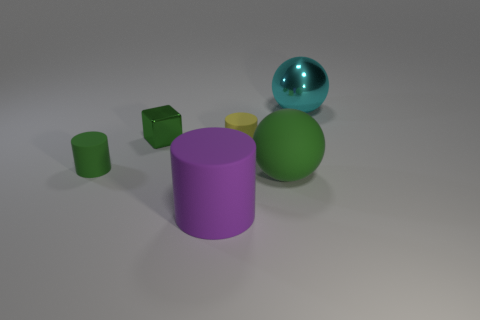Add 2 tiny green cylinders. How many objects exist? 8 Subtract all spheres. How many objects are left? 4 Subtract 0 red balls. How many objects are left? 6 Subtract all large brown cylinders. Subtract all rubber balls. How many objects are left? 5 Add 2 tiny metal cubes. How many tiny metal cubes are left? 3 Add 5 blocks. How many blocks exist? 6 